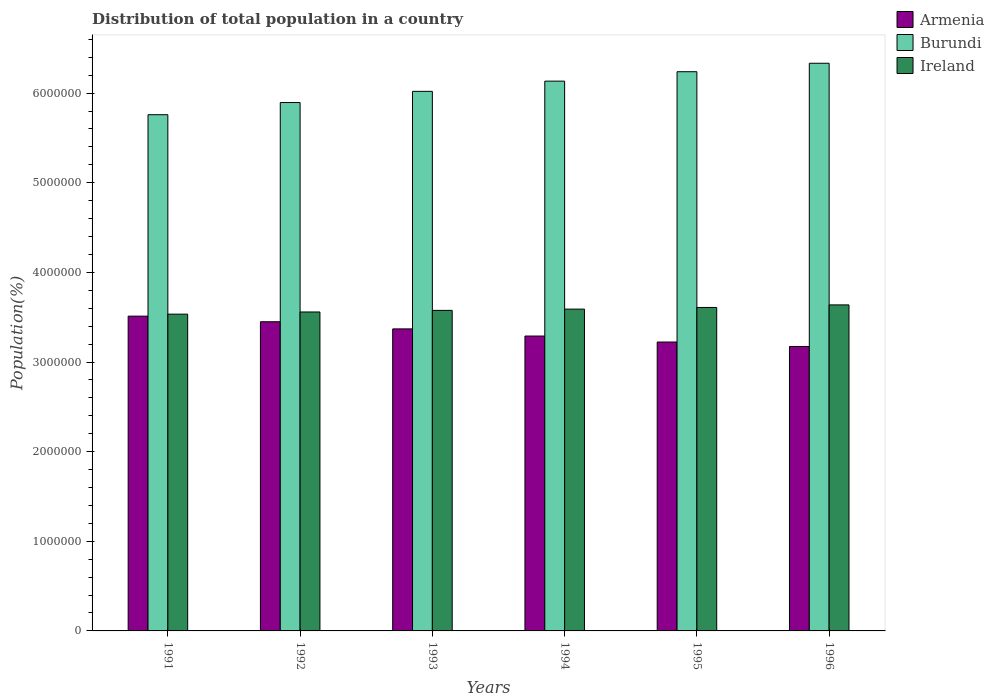Are the number of bars on each tick of the X-axis equal?
Your answer should be very brief. Yes. How many bars are there on the 4th tick from the left?
Provide a short and direct response. 3. What is the population of in Burundi in 1994?
Offer a terse response. 6.13e+06. Across all years, what is the maximum population of in Armenia?
Your response must be concise. 3.51e+06. Across all years, what is the minimum population of in Burundi?
Give a very brief answer. 5.76e+06. In which year was the population of in Armenia maximum?
Make the answer very short. 1991. In which year was the population of in Armenia minimum?
Provide a short and direct response. 1996. What is the total population of in Armenia in the graph?
Your answer should be compact. 2.00e+07. What is the difference between the population of in Burundi in 1994 and that in 1995?
Provide a succinct answer. -1.05e+05. What is the difference between the population of in Ireland in 1993 and the population of in Burundi in 1996?
Ensure brevity in your answer.  -2.76e+06. What is the average population of in Armenia per year?
Give a very brief answer. 3.34e+06. In the year 1993, what is the difference between the population of in Armenia and population of in Ireland?
Your answer should be compact. -2.07e+05. What is the ratio of the population of in Armenia in 1993 to that in 1995?
Make the answer very short. 1.05. Is the difference between the population of in Armenia in 1992 and 1995 greater than the difference between the population of in Ireland in 1992 and 1995?
Provide a succinct answer. Yes. What is the difference between the highest and the second highest population of in Burundi?
Give a very brief answer. 9.44e+04. What is the difference between the highest and the lowest population of in Ireland?
Provide a short and direct response. 1.03e+05. Is the sum of the population of in Armenia in 1992 and 1996 greater than the maximum population of in Ireland across all years?
Ensure brevity in your answer.  Yes. What does the 3rd bar from the left in 1996 represents?
Keep it short and to the point. Ireland. What does the 3rd bar from the right in 1994 represents?
Your answer should be compact. Armenia. How many bars are there?
Provide a short and direct response. 18. Are all the bars in the graph horizontal?
Offer a terse response. No. What is the difference between two consecutive major ticks on the Y-axis?
Give a very brief answer. 1.00e+06. Does the graph contain grids?
Ensure brevity in your answer.  No. Where does the legend appear in the graph?
Your answer should be very brief. Top right. How are the legend labels stacked?
Offer a terse response. Vertical. What is the title of the graph?
Offer a very short reply. Distribution of total population in a country. What is the label or title of the X-axis?
Your answer should be compact. Years. What is the label or title of the Y-axis?
Provide a succinct answer. Population(%). What is the Population(%) in Armenia in 1991?
Ensure brevity in your answer.  3.51e+06. What is the Population(%) of Burundi in 1991?
Your response must be concise. 5.76e+06. What is the Population(%) in Ireland in 1991?
Keep it short and to the point. 3.53e+06. What is the Population(%) of Armenia in 1992?
Offer a terse response. 3.45e+06. What is the Population(%) of Burundi in 1992?
Provide a succinct answer. 5.90e+06. What is the Population(%) in Ireland in 1992?
Provide a short and direct response. 3.56e+06. What is the Population(%) of Armenia in 1993?
Give a very brief answer. 3.37e+06. What is the Population(%) of Burundi in 1993?
Give a very brief answer. 6.02e+06. What is the Population(%) in Ireland in 1993?
Provide a succinct answer. 3.58e+06. What is the Population(%) of Armenia in 1994?
Offer a very short reply. 3.29e+06. What is the Population(%) of Burundi in 1994?
Your answer should be compact. 6.13e+06. What is the Population(%) in Ireland in 1994?
Provide a succinct answer. 3.59e+06. What is the Population(%) of Armenia in 1995?
Ensure brevity in your answer.  3.22e+06. What is the Population(%) in Burundi in 1995?
Provide a short and direct response. 6.24e+06. What is the Population(%) of Ireland in 1995?
Provide a short and direct response. 3.61e+06. What is the Population(%) in Armenia in 1996?
Provide a succinct answer. 3.17e+06. What is the Population(%) in Burundi in 1996?
Give a very brief answer. 6.33e+06. What is the Population(%) in Ireland in 1996?
Ensure brevity in your answer.  3.64e+06. Across all years, what is the maximum Population(%) in Armenia?
Offer a terse response. 3.51e+06. Across all years, what is the maximum Population(%) of Burundi?
Keep it short and to the point. 6.33e+06. Across all years, what is the maximum Population(%) of Ireland?
Your answer should be compact. 3.64e+06. Across all years, what is the minimum Population(%) of Armenia?
Your answer should be very brief. 3.17e+06. Across all years, what is the minimum Population(%) in Burundi?
Offer a terse response. 5.76e+06. Across all years, what is the minimum Population(%) of Ireland?
Give a very brief answer. 3.53e+06. What is the total Population(%) of Armenia in the graph?
Your response must be concise. 2.00e+07. What is the total Population(%) in Burundi in the graph?
Your answer should be compact. 3.64e+07. What is the total Population(%) of Ireland in the graph?
Your response must be concise. 2.15e+07. What is the difference between the Population(%) in Armenia in 1991 and that in 1992?
Provide a short and direct response. 6.24e+04. What is the difference between the Population(%) in Burundi in 1991 and that in 1992?
Give a very brief answer. -1.36e+05. What is the difference between the Population(%) of Ireland in 1991 and that in 1992?
Offer a terse response. -2.42e+04. What is the difference between the Population(%) of Armenia in 1991 and that in 1993?
Keep it short and to the point. 1.42e+05. What is the difference between the Population(%) of Burundi in 1991 and that in 1993?
Ensure brevity in your answer.  -2.60e+05. What is the difference between the Population(%) of Ireland in 1991 and that in 1993?
Offer a terse response. -4.20e+04. What is the difference between the Population(%) of Armenia in 1991 and that in 1994?
Your answer should be very brief. 2.22e+05. What is the difference between the Population(%) of Burundi in 1991 and that in 1994?
Your answer should be compact. -3.75e+05. What is the difference between the Population(%) of Ireland in 1991 and that in 1994?
Provide a short and direct response. -5.62e+04. What is the difference between the Population(%) of Armenia in 1991 and that in 1995?
Your answer should be compact. 2.89e+05. What is the difference between the Population(%) in Burundi in 1991 and that in 1995?
Keep it short and to the point. -4.80e+05. What is the difference between the Population(%) of Ireland in 1991 and that in 1995?
Make the answer very short. -7.46e+04. What is the difference between the Population(%) in Armenia in 1991 and that in 1996?
Ensure brevity in your answer.  3.38e+05. What is the difference between the Population(%) in Burundi in 1991 and that in 1996?
Keep it short and to the point. -5.74e+05. What is the difference between the Population(%) of Ireland in 1991 and that in 1996?
Keep it short and to the point. -1.03e+05. What is the difference between the Population(%) of Armenia in 1992 and that in 1993?
Your answer should be very brief. 7.98e+04. What is the difference between the Population(%) in Burundi in 1992 and that in 1993?
Give a very brief answer. -1.25e+05. What is the difference between the Population(%) of Ireland in 1992 and that in 1993?
Offer a very short reply. -1.78e+04. What is the difference between the Population(%) in Armenia in 1992 and that in 1994?
Provide a short and direct response. 1.60e+05. What is the difference between the Population(%) in Burundi in 1992 and that in 1994?
Offer a very short reply. -2.39e+05. What is the difference between the Population(%) of Ireland in 1992 and that in 1994?
Your answer should be compact. -3.20e+04. What is the difference between the Population(%) of Armenia in 1992 and that in 1995?
Ensure brevity in your answer.  2.26e+05. What is the difference between the Population(%) of Burundi in 1992 and that in 1995?
Make the answer very short. -3.44e+05. What is the difference between the Population(%) in Ireland in 1992 and that in 1995?
Your answer should be compact. -5.04e+04. What is the difference between the Population(%) of Armenia in 1992 and that in 1996?
Give a very brief answer. 2.76e+05. What is the difference between the Population(%) of Burundi in 1992 and that in 1996?
Offer a very short reply. -4.38e+05. What is the difference between the Population(%) of Ireland in 1992 and that in 1996?
Your answer should be compact. -7.91e+04. What is the difference between the Population(%) in Armenia in 1993 and that in 1994?
Your answer should be very brief. 7.97e+04. What is the difference between the Population(%) in Burundi in 1993 and that in 1994?
Offer a very short reply. -1.14e+05. What is the difference between the Population(%) of Ireland in 1993 and that in 1994?
Keep it short and to the point. -1.41e+04. What is the difference between the Population(%) of Armenia in 1993 and that in 1995?
Provide a short and direct response. 1.46e+05. What is the difference between the Population(%) in Burundi in 1993 and that in 1995?
Your answer should be very brief. -2.19e+05. What is the difference between the Population(%) in Ireland in 1993 and that in 1995?
Ensure brevity in your answer.  -3.26e+04. What is the difference between the Population(%) in Armenia in 1993 and that in 1996?
Provide a short and direct response. 1.96e+05. What is the difference between the Population(%) of Burundi in 1993 and that in 1996?
Your response must be concise. -3.14e+05. What is the difference between the Population(%) of Ireland in 1993 and that in 1996?
Provide a short and direct response. -6.12e+04. What is the difference between the Population(%) in Armenia in 1994 and that in 1995?
Your answer should be compact. 6.68e+04. What is the difference between the Population(%) of Burundi in 1994 and that in 1995?
Keep it short and to the point. -1.05e+05. What is the difference between the Population(%) of Ireland in 1994 and that in 1995?
Offer a very short reply. -1.85e+04. What is the difference between the Population(%) in Armenia in 1994 and that in 1996?
Offer a very short reply. 1.17e+05. What is the difference between the Population(%) in Burundi in 1994 and that in 1996?
Your answer should be compact. -1.99e+05. What is the difference between the Population(%) of Ireland in 1994 and that in 1996?
Offer a terse response. -4.71e+04. What is the difference between the Population(%) in Armenia in 1995 and that in 1996?
Ensure brevity in your answer.  4.97e+04. What is the difference between the Population(%) of Burundi in 1995 and that in 1996?
Ensure brevity in your answer.  -9.44e+04. What is the difference between the Population(%) in Ireland in 1995 and that in 1996?
Your response must be concise. -2.87e+04. What is the difference between the Population(%) in Armenia in 1991 and the Population(%) in Burundi in 1992?
Your answer should be compact. -2.38e+06. What is the difference between the Population(%) in Armenia in 1991 and the Population(%) in Ireland in 1992?
Provide a short and direct response. -4.65e+04. What is the difference between the Population(%) of Burundi in 1991 and the Population(%) of Ireland in 1992?
Offer a very short reply. 2.20e+06. What is the difference between the Population(%) of Armenia in 1991 and the Population(%) of Burundi in 1993?
Offer a terse response. -2.51e+06. What is the difference between the Population(%) in Armenia in 1991 and the Population(%) in Ireland in 1993?
Keep it short and to the point. -6.43e+04. What is the difference between the Population(%) in Burundi in 1991 and the Population(%) in Ireland in 1993?
Give a very brief answer. 2.18e+06. What is the difference between the Population(%) in Armenia in 1991 and the Population(%) in Burundi in 1994?
Offer a terse response. -2.62e+06. What is the difference between the Population(%) in Armenia in 1991 and the Population(%) in Ireland in 1994?
Your response must be concise. -7.85e+04. What is the difference between the Population(%) in Burundi in 1991 and the Population(%) in Ireland in 1994?
Give a very brief answer. 2.17e+06. What is the difference between the Population(%) in Armenia in 1991 and the Population(%) in Burundi in 1995?
Your answer should be very brief. -2.73e+06. What is the difference between the Population(%) of Armenia in 1991 and the Population(%) of Ireland in 1995?
Give a very brief answer. -9.69e+04. What is the difference between the Population(%) in Burundi in 1991 and the Population(%) in Ireland in 1995?
Ensure brevity in your answer.  2.15e+06. What is the difference between the Population(%) of Armenia in 1991 and the Population(%) of Burundi in 1996?
Your answer should be very brief. -2.82e+06. What is the difference between the Population(%) in Armenia in 1991 and the Population(%) in Ireland in 1996?
Ensure brevity in your answer.  -1.26e+05. What is the difference between the Population(%) in Burundi in 1991 and the Population(%) in Ireland in 1996?
Keep it short and to the point. 2.12e+06. What is the difference between the Population(%) of Armenia in 1992 and the Population(%) of Burundi in 1993?
Provide a short and direct response. -2.57e+06. What is the difference between the Population(%) in Armenia in 1992 and the Population(%) in Ireland in 1993?
Keep it short and to the point. -1.27e+05. What is the difference between the Population(%) of Burundi in 1992 and the Population(%) of Ireland in 1993?
Give a very brief answer. 2.32e+06. What is the difference between the Population(%) in Armenia in 1992 and the Population(%) in Burundi in 1994?
Ensure brevity in your answer.  -2.68e+06. What is the difference between the Population(%) in Armenia in 1992 and the Population(%) in Ireland in 1994?
Your response must be concise. -1.41e+05. What is the difference between the Population(%) of Burundi in 1992 and the Population(%) of Ireland in 1994?
Your answer should be very brief. 2.30e+06. What is the difference between the Population(%) in Armenia in 1992 and the Population(%) in Burundi in 1995?
Make the answer very short. -2.79e+06. What is the difference between the Population(%) of Armenia in 1992 and the Population(%) of Ireland in 1995?
Make the answer very short. -1.59e+05. What is the difference between the Population(%) in Burundi in 1992 and the Population(%) in Ireland in 1995?
Provide a succinct answer. 2.29e+06. What is the difference between the Population(%) in Armenia in 1992 and the Population(%) in Burundi in 1996?
Provide a succinct answer. -2.88e+06. What is the difference between the Population(%) of Armenia in 1992 and the Population(%) of Ireland in 1996?
Offer a terse response. -1.88e+05. What is the difference between the Population(%) in Burundi in 1992 and the Population(%) in Ireland in 1996?
Provide a succinct answer. 2.26e+06. What is the difference between the Population(%) of Armenia in 1993 and the Population(%) of Burundi in 1994?
Provide a succinct answer. -2.76e+06. What is the difference between the Population(%) of Armenia in 1993 and the Population(%) of Ireland in 1994?
Provide a short and direct response. -2.21e+05. What is the difference between the Population(%) of Burundi in 1993 and the Population(%) of Ireland in 1994?
Keep it short and to the point. 2.43e+06. What is the difference between the Population(%) of Armenia in 1993 and the Population(%) of Burundi in 1995?
Ensure brevity in your answer.  -2.87e+06. What is the difference between the Population(%) of Armenia in 1993 and the Population(%) of Ireland in 1995?
Provide a succinct answer. -2.39e+05. What is the difference between the Population(%) in Burundi in 1993 and the Population(%) in Ireland in 1995?
Offer a terse response. 2.41e+06. What is the difference between the Population(%) in Armenia in 1993 and the Population(%) in Burundi in 1996?
Provide a short and direct response. -2.96e+06. What is the difference between the Population(%) in Armenia in 1993 and the Population(%) in Ireland in 1996?
Ensure brevity in your answer.  -2.68e+05. What is the difference between the Population(%) of Burundi in 1993 and the Population(%) of Ireland in 1996?
Give a very brief answer. 2.38e+06. What is the difference between the Population(%) of Armenia in 1994 and the Population(%) of Burundi in 1995?
Offer a terse response. -2.95e+06. What is the difference between the Population(%) of Armenia in 1994 and the Population(%) of Ireland in 1995?
Your answer should be very brief. -3.19e+05. What is the difference between the Population(%) of Burundi in 1994 and the Population(%) of Ireland in 1995?
Keep it short and to the point. 2.53e+06. What is the difference between the Population(%) of Armenia in 1994 and the Population(%) of Burundi in 1996?
Keep it short and to the point. -3.04e+06. What is the difference between the Population(%) of Armenia in 1994 and the Population(%) of Ireland in 1996?
Make the answer very short. -3.48e+05. What is the difference between the Population(%) of Burundi in 1994 and the Population(%) of Ireland in 1996?
Provide a short and direct response. 2.50e+06. What is the difference between the Population(%) of Armenia in 1995 and the Population(%) of Burundi in 1996?
Provide a short and direct response. -3.11e+06. What is the difference between the Population(%) of Armenia in 1995 and the Population(%) of Ireland in 1996?
Give a very brief answer. -4.14e+05. What is the difference between the Population(%) of Burundi in 1995 and the Population(%) of Ireland in 1996?
Make the answer very short. 2.60e+06. What is the average Population(%) in Armenia per year?
Keep it short and to the point. 3.34e+06. What is the average Population(%) of Burundi per year?
Give a very brief answer. 6.06e+06. What is the average Population(%) in Ireland per year?
Your response must be concise. 3.58e+06. In the year 1991, what is the difference between the Population(%) in Armenia and Population(%) in Burundi?
Offer a very short reply. -2.25e+06. In the year 1991, what is the difference between the Population(%) of Armenia and Population(%) of Ireland?
Provide a short and direct response. -2.23e+04. In the year 1991, what is the difference between the Population(%) in Burundi and Population(%) in Ireland?
Offer a very short reply. 2.23e+06. In the year 1992, what is the difference between the Population(%) of Armenia and Population(%) of Burundi?
Give a very brief answer. -2.45e+06. In the year 1992, what is the difference between the Population(%) of Armenia and Population(%) of Ireland?
Keep it short and to the point. -1.09e+05. In the year 1992, what is the difference between the Population(%) of Burundi and Population(%) of Ireland?
Provide a succinct answer. 2.34e+06. In the year 1993, what is the difference between the Population(%) of Armenia and Population(%) of Burundi?
Give a very brief answer. -2.65e+06. In the year 1993, what is the difference between the Population(%) of Armenia and Population(%) of Ireland?
Make the answer very short. -2.07e+05. In the year 1993, what is the difference between the Population(%) of Burundi and Population(%) of Ireland?
Make the answer very short. 2.44e+06. In the year 1994, what is the difference between the Population(%) in Armenia and Population(%) in Burundi?
Your response must be concise. -2.84e+06. In the year 1994, what is the difference between the Population(%) of Armenia and Population(%) of Ireland?
Provide a short and direct response. -3.00e+05. In the year 1994, what is the difference between the Population(%) of Burundi and Population(%) of Ireland?
Give a very brief answer. 2.54e+06. In the year 1995, what is the difference between the Population(%) in Armenia and Population(%) in Burundi?
Your answer should be very brief. -3.02e+06. In the year 1995, what is the difference between the Population(%) in Armenia and Population(%) in Ireland?
Your answer should be very brief. -3.86e+05. In the year 1995, what is the difference between the Population(%) in Burundi and Population(%) in Ireland?
Offer a terse response. 2.63e+06. In the year 1996, what is the difference between the Population(%) in Armenia and Population(%) in Burundi?
Keep it short and to the point. -3.16e+06. In the year 1996, what is the difference between the Population(%) of Armenia and Population(%) of Ireland?
Provide a succinct answer. -4.64e+05. In the year 1996, what is the difference between the Population(%) of Burundi and Population(%) of Ireland?
Keep it short and to the point. 2.70e+06. What is the ratio of the Population(%) of Armenia in 1991 to that in 1992?
Ensure brevity in your answer.  1.02. What is the ratio of the Population(%) of Burundi in 1991 to that in 1992?
Keep it short and to the point. 0.98. What is the ratio of the Population(%) in Armenia in 1991 to that in 1993?
Provide a succinct answer. 1.04. What is the ratio of the Population(%) of Burundi in 1991 to that in 1993?
Offer a very short reply. 0.96. What is the ratio of the Population(%) of Ireland in 1991 to that in 1993?
Keep it short and to the point. 0.99. What is the ratio of the Population(%) of Armenia in 1991 to that in 1994?
Provide a succinct answer. 1.07. What is the ratio of the Population(%) in Burundi in 1991 to that in 1994?
Provide a succinct answer. 0.94. What is the ratio of the Population(%) of Ireland in 1991 to that in 1994?
Make the answer very short. 0.98. What is the ratio of the Population(%) of Armenia in 1991 to that in 1995?
Ensure brevity in your answer.  1.09. What is the ratio of the Population(%) of Ireland in 1991 to that in 1995?
Provide a short and direct response. 0.98. What is the ratio of the Population(%) in Armenia in 1991 to that in 1996?
Make the answer very short. 1.11. What is the ratio of the Population(%) of Burundi in 1991 to that in 1996?
Your response must be concise. 0.91. What is the ratio of the Population(%) in Ireland in 1991 to that in 1996?
Your answer should be very brief. 0.97. What is the ratio of the Population(%) in Armenia in 1992 to that in 1993?
Your answer should be compact. 1.02. What is the ratio of the Population(%) in Burundi in 1992 to that in 1993?
Provide a short and direct response. 0.98. What is the ratio of the Population(%) in Ireland in 1992 to that in 1993?
Offer a terse response. 0.99. What is the ratio of the Population(%) of Armenia in 1992 to that in 1994?
Offer a terse response. 1.05. What is the ratio of the Population(%) in Burundi in 1992 to that in 1994?
Give a very brief answer. 0.96. What is the ratio of the Population(%) in Armenia in 1992 to that in 1995?
Provide a short and direct response. 1.07. What is the ratio of the Population(%) in Burundi in 1992 to that in 1995?
Ensure brevity in your answer.  0.94. What is the ratio of the Population(%) of Ireland in 1992 to that in 1995?
Your answer should be very brief. 0.99. What is the ratio of the Population(%) in Armenia in 1992 to that in 1996?
Offer a terse response. 1.09. What is the ratio of the Population(%) of Burundi in 1992 to that in 1996?
Your answer should be compact. 0.93. What is the ratio of the Population(%) in Ireland in 1992 to that in 1996?
Your answer should be compact. 0.98. What is the ratio of the Population(%) in Armenia in 1993 to that in 1994?
Provide a succinct answer. 1.02. What is the ratio of the Population(%) of Burundi in 1993 to that in 1994?
Offer a very short reply. 0.98. What is the ratio of the Population(%) of Armenia in 1993 to that in 1995?
Your response must be concise. 1.05. What is the ratio of the Population(%) in Burundi in 1993 to that in 1995?
Give a very brief answer. 0.96. What is the ratio of the Population(%) of Ireland in 1993 to that in 1995?
Offer a very short reply. 0.99. What is the ratio of the Population(%) of Armenia in 1993 to that in 1996?
Ensure brevity in your answer.  1.06. What is the ratio of the Population(%) of Burundi in 1993 to that in 1996?
Offer a terse response. 0.95. What is the ratio of the Population(%) of Ireland in 1993 to that in 1996?
Your response must be concise. 0.98. What is the ratio of the Population(%) of Armenia in 1994 to that in 1995?
Make the answer very short. 1.02. What is the ratio of the Population(%) in Burundi in 1994 to that in 1995?
Offer a terse response. 0.98. What is the ratio of the Population(%) of Ireland in 1994 to that in 1995?
Provide a short and direct response. 0.99. What is the ratio of the Population(%) in Armenia in 1994 to that in 1996?
Give a very brief answer. 1.04. What is the ratio of the Population(%) in Burundi in 1994 to that in 1996?
Your answer should be compact. 0.97. What is the ratio of the Population(%) in Armenia in 1995 to that in 1996?
Your response must be concise. 1.02. What is the ratio of the Population(%) in Burundi in 1995 to that in 1996?
Your answer should be very brief. 0.99. What is the ratio of the Population(%) of Ireland in 1995 to that in 1996?
Your answer should be very brief. 0.99. What is the difference between the highest and the second highest Population(%) of Armenia?
Provide a short and direct response. 6.24e+04. What is the difference between the highest and the second highest Population(%) of Burundi?
Offer a very short reply. 9.44e+04. What is the difference between the highest and the second highest Population(%) in Ireland?
Make the answer very short. 2.87e+04. What is the difference between the highest and the lowest Population(%) of Armenia?
Provide a short and direct response. 3.38e+05. What is the difference between the highest and the lowest Population(%) of Burundi?
Ensure brevity in your answer.  5.74e+05. What is the difference between the highest and the lowest Population(%) in Ireland?
Offer a terse response. 1.03e+05. 